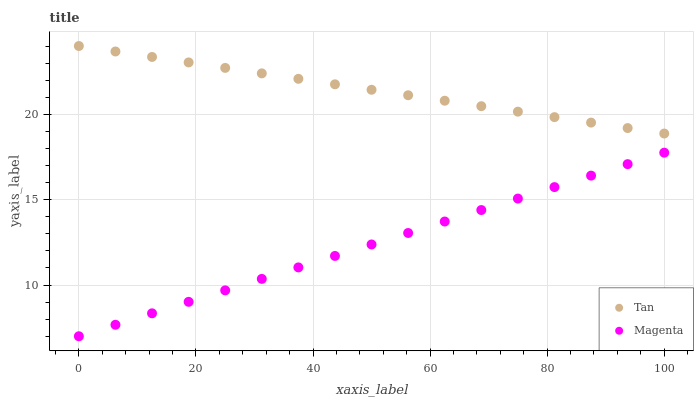Does Magenta have the minimum area under the curve?
Answer yes or no. Yes. Does Tan have the maximum area under the curve?
Answer yes or no. Yes. Does Magenta have the maximum area under the curve?
Answer yes or no. No. Is Magenta the smoothest?
Answer yes or no. Yes. Is Tan the roughest?
Answer yes or no. Yes. Is Magenta the roughest?
Answer yes or no. No. Does Magenta have the lowest value?
Answer yes or no. Yes. Does Tan have the highest value?
Answer yes or no. Yes. Does Magenta have the highest value?
Answer yes or no. No. Is Magenta less than Tan?
Answer yes or no. Yes. Is Tan greater than Magenta?
Answer yes or no. Yes. Does Magenta intersect Tan?
Answer yes or no. No. 